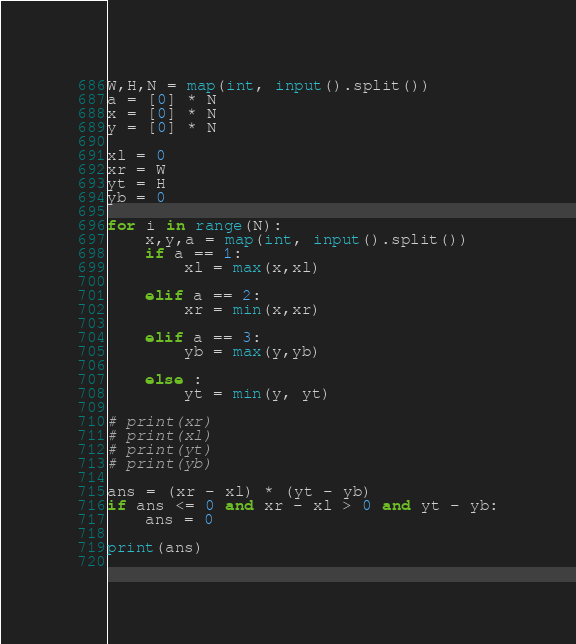<code> <loc_0><loc_0><loc_500><loc_500><_Python_>W,H,N = map(int, input().split())
a = [0] * N
x = [0] * N
y = [0] * N

xl = 0
xr = W
yt = H
yb = 0

for i in range(N):
    x,y,a = map(int, input().split())
    if a == 1:
        xl = max(x,xl)

    elif a == 2:
        xr = min(x,xr)
    
    elif a == 3:
        yb = max(y,yb)    

    else :
        yt = min(y, yt)

# print(xr)
# print(xl)
# print(yt)
# print(yb)

ans = (xr - xl) * (yt - yb)
if ans <= 0 and xr - xl > 0 and yt - yb:
    ans = 0

print(ans)
        </code> 